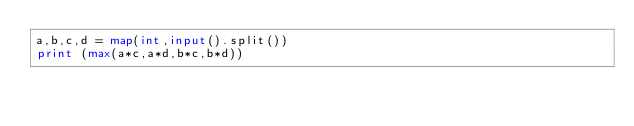<code> <loc_0><loc_0><loc_500><loc_500><_Python_>a,b,c,d = map(int,input().split())
print (max(a*c,a*d,b*c,b*d))
</code> 